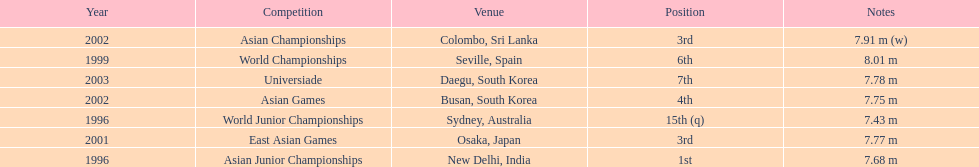In what year did someone first achieve the 3rd place? 2001. 